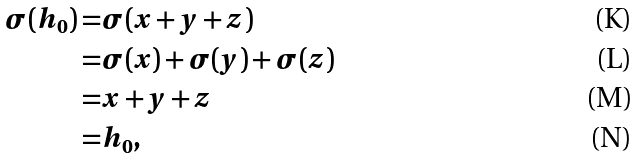<formula> <loc_0><loc_0><loc_500><loc_500>\sigma ( h _ { 0 } ) = & \sigma ( x + y + z ) \\ = & \sigma ( x ) + \sigma ( y ) + \sigma ( z ) \\ = & x + y + z \\ = & h _ { 0 } ,</formula> 